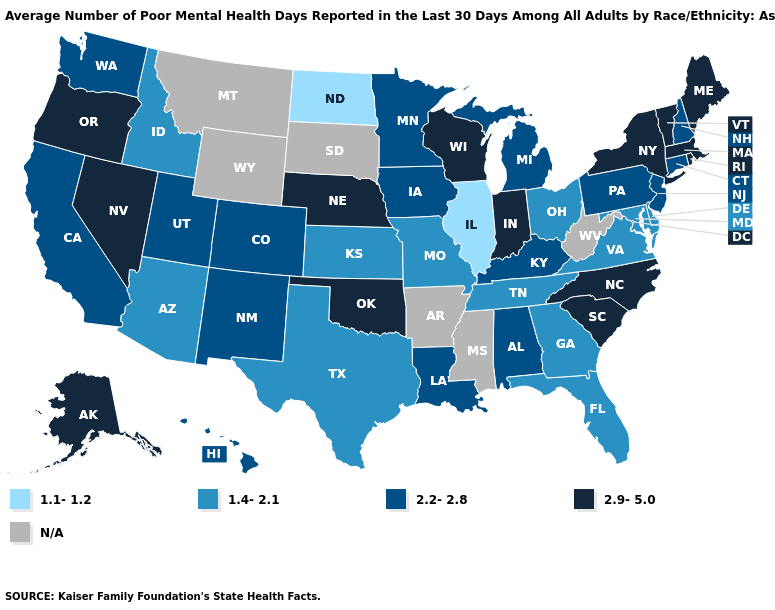What is the value of Oregon?
Write a very short answer. 2.9-5.0. Does Nevada have the highest value in the West?
Short answer required. Yes. Name the states that have a value in the range 2.9-5.0?
Quick response, please. Alaska, Indiana, Maine, Massachusetts, Nebraska, Nevada, New York, North Carolina, Oklahoma, Oregon, Rhode Island, South Carolina, Vermont, Wisconsin. Does the first symbol in the legend represent the smallest category?
Keep it brief. Yes. Among the states that border Colorado , which have the highest value?
Give a very brief answer. Nebraska, Oklahoma. What is the value of Florida?
Be succinct. 1.4-2.1. What is the lowest value in the Northeast?
Quick response, please. 2.2-2.8. Name the states that have a value in the range 2.2-2.8?
Concise answer only. Alabama, California, Colorado, Connecticut, Hawaii, Iowa, Kentucky, Louisiana, Michigan, Minnesota, New Hampshire, New Jersey, New Mexico, Pennsylvania, Utah, Washington. Name the states that have a value in the range N/A?
Keep it brief. Arkansas, Mississippi, Montana, South Dakota, West Virginia, Wyoming. Among the states that border New Hampshire , which have the lowest value?
Quick response, please. Maine, Massachusetts, Vermont. Among the states that border Massachusetts , which have the highest value?
Concise answer only. New York, Rhode Island, Vermont. What is the value of Georgia?
Keep it brief. 1.4-2.1. Which states have the highest value in the USA?
Give a very brief answer. Alaska, Indiana, Maine, Massachusetts, Nebraska, Nevada, New York, North Carolina, Oklahoma, Oregon, Rhode Island, South Carolina, Vermont, Wisconsin. What is the value of South Carolina?
Write a very short answer. 2.9-5.0. 